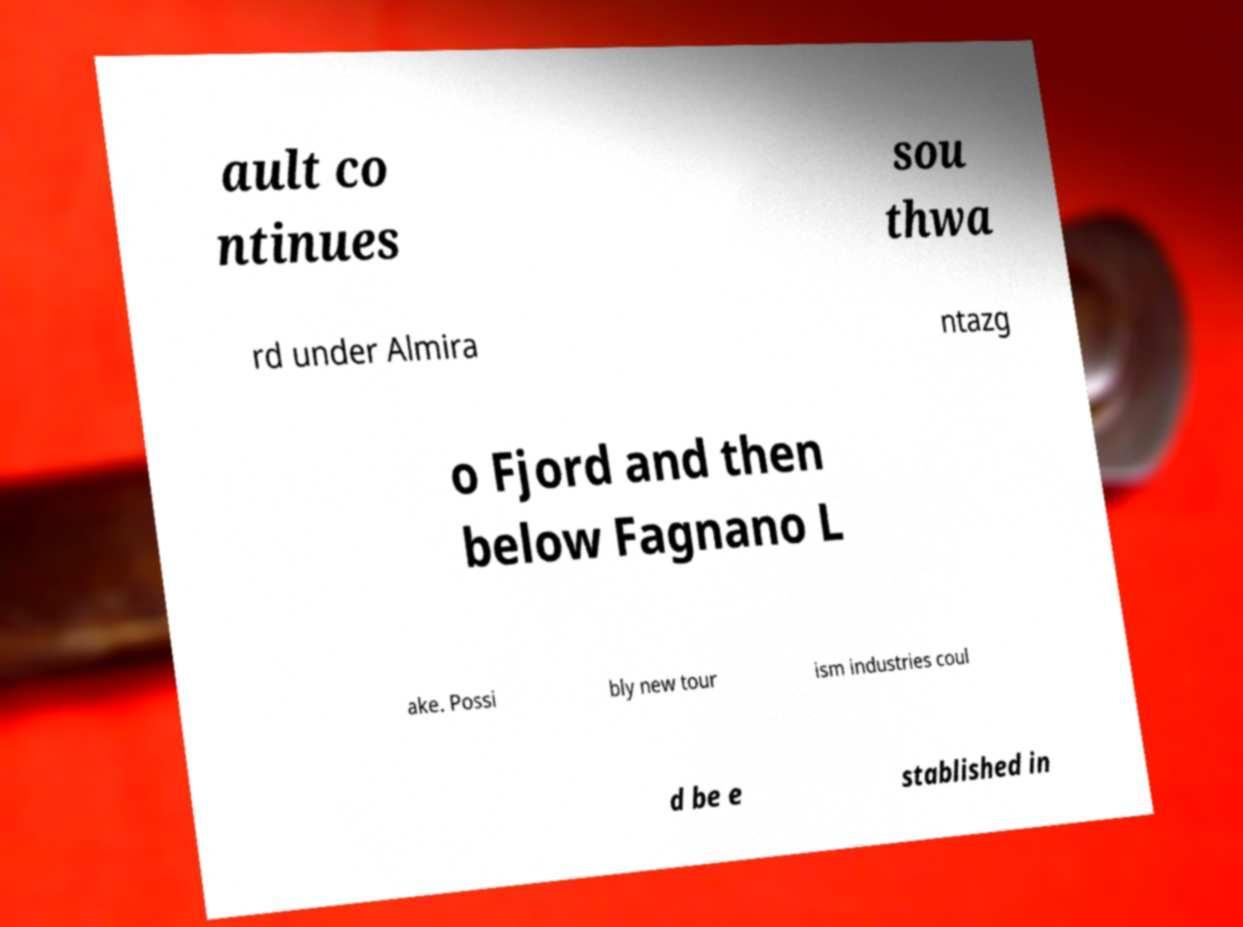Please identify and transcribe the text found in this image. ault co ntinues sou thwa rd under Almira ntazg o Fjord and then below Fagnano L ake. Possi bly new tour ism industries coul d be e stablished in 